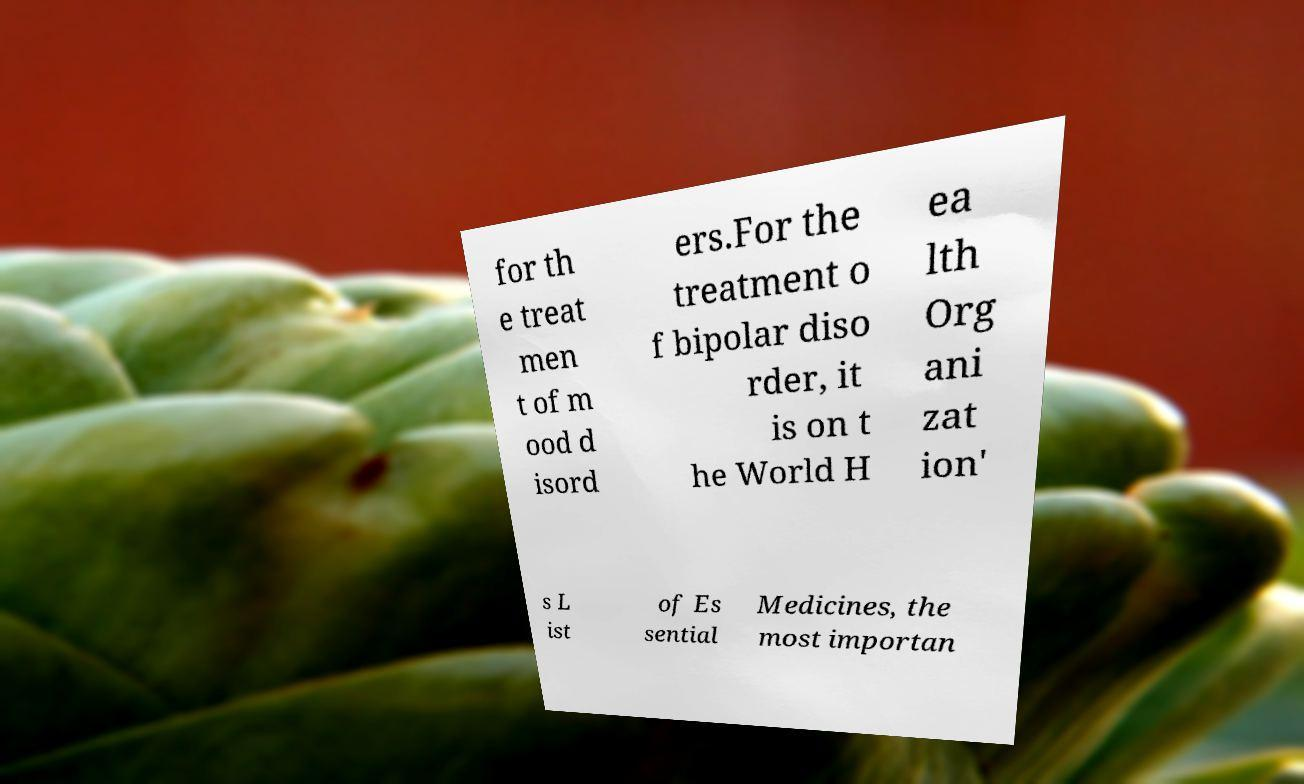Please read and relay the text visible in this image. What does it say? for th e treat men t of m ood d isord ers.For the treatment o f bipolar diso rder, it is on t he World H ea lth Org ani zat ion' s L ist of Es sential Medicines, the most importan 